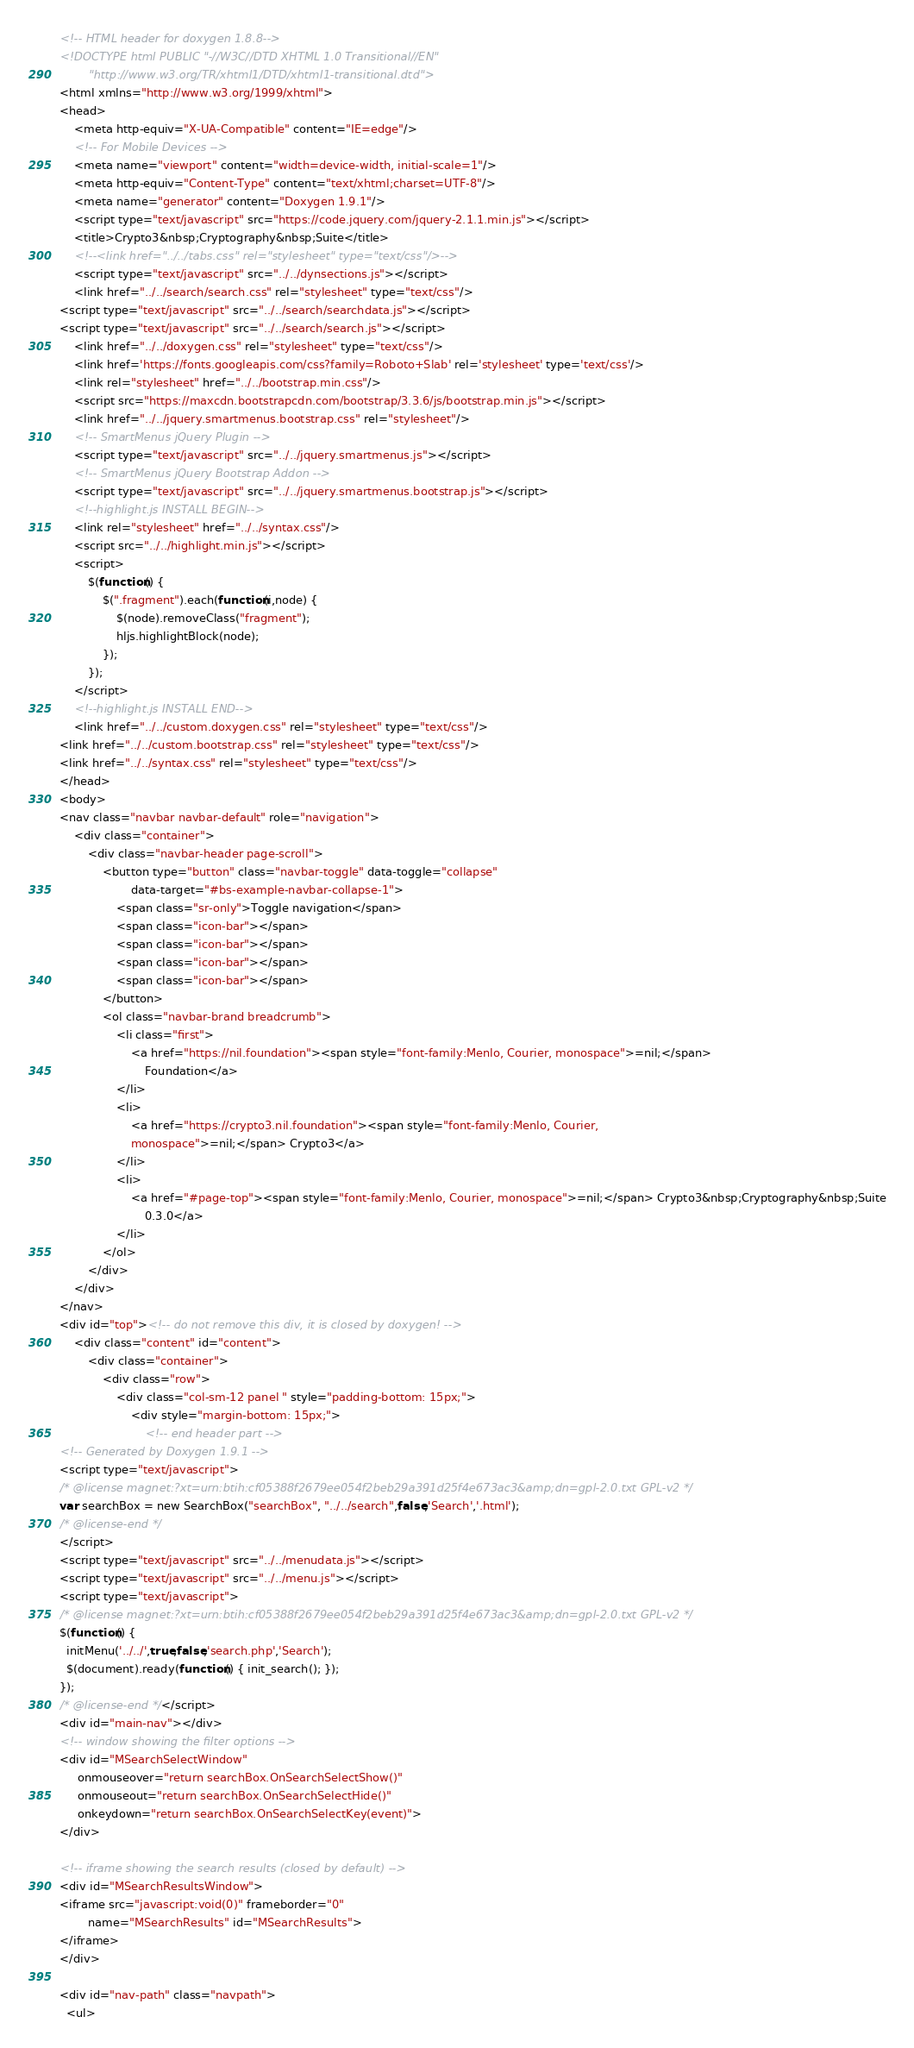<code> <loc_0><loc_0><loc_500><loc_500><_HTML_><!-- HTML header for doxygen 1.8.8-->
<!DOCTYPE html PUBLIC "-//W3C//DTD XHTML 1.0 Transitional//EN"
        "http://www.w3.org/TR/xhtml1/DTD/xhtml1-transitional.dtd">
<html xmlns="http://www.w3.org/1999/xhtml">
<head>
    <meta http-equiv="X-UA-Compatible" content="IE=edge"/>
    <!-- For Mobile Devices -->
    <meta name="viewport" content="width=device-width, initial-scale=1"/>
    <meta http-equiv="Content-Type" content="text/xhtml;charset=UTF-8"/>
    <meta name="generator" content="Doxygen 1.9.1"/>
    <script type="text/javascript" src="https://code.jquery.com/jquery-2.1.1.min.js"></script>
    <title>Crypto3&nbsp;Cryptography&nbsp;Suite</title>
    <!--<link href="../../tabs.css" rel="stylesheet" type="text/css"/>-->
    <script type="text/javascript" src="../../dynsections.js"></script>
    <link href="../../search/search.css" rel="stylesheet" type="text/css"/>
<script type="text/javascript" src="../../search/searchdata.js"></script>
<script type="text/javascript" src="../../search/search.js"></script>
    <link href="../../doxygen.css" rel="stylesheet" type="text/css"/>
    <link href='https://fonts.googleapis.com/css?family=Roboto+Slab' rel='stylesheet' type='text/css'/>
    <link rel="stylesheet" href="../../bootstrap.min.css"/>
    <script src="https://maxcdn.bootstrapcdn.com/bootstrap/3.3.6/js/bootstrap.min.js"></script>
    <link href="../../jquery.smartmenus.bootstrap.css" rel="stylesheet"/>
    <!-- SmartMenus jQuery Plugin -->
    <script type="text/javascript" src="../../jquery.smartmenus.js"></script>
    <!-- SmartMenus jQuery Bootstrap Addon -->
    <script type="text/javascript" src="../../jquery.smartmenus.bootstrap.js"></script>
    <!--highlight.js INSTALL BEGIN-->
    <link rel="stylesheet" href="../../syntax.css"/>
    <script src="../../highlight.min.js"></script>
    <script>
        $(function() {
            $(".fragment").each(function(i,node) {
                $(node).removeClass("fragment");
                hljs.highlightBlock(node);
            });
        });
    </script>
    <!--highlight.js INSTALL END-->
    <link href="../../custom.doxygen.css" rel="stylesheet" type="text/css"/>
<link href="../../custom.bootstrap.css" rel="stylesheet" type="text/css"/>
<link href="../../syntax.css" rel="stylesheet" type="text/css"/>
</head>
<body>
<nav class="navbar navbar-default" role="navigation">
    <div class="container">
        <div class="navbar-header page-scroll">
            <button type="button" class="navbar-toggle" data-toggle="collapse"
                    data-target="#bs-example-navbar-collapse-1">
                <span class="sr-only">Toggle navigation</span>
                <span class="icon-bar"></span>
                <span class="icon-bar"></span>
                <span class="icon-bar"></span>
                <span class="icon-bar"></span>
            </button>
            <ol class="navbar-brand breadcrumb">
                <li class="first">
                    <a href="https://nil.foundation"><span style="font-family:Menlo, Courier, monospace">=nil;</span>
                        Foundation</a>
                </li>
                <li>
                    <a href="https://crypto3.nil.foundation"><span style="font-family:Menlo, Courier,
                    monospace">=nil;</span> Crypto3</a>
                </li>
                <li>
                    <a href="#page-top"><span style="font-family:Menlo, Courier, monospace">=nil;</span> Crypto3&nbsp;Cryptography&nbsp;Suite
                        0.3.0</a>
                </li>
            </ol>
        </div>
    </div>
</nav>
<div id="top"><!-- do not remove this div, it is closed by doxygen! -->
    <div class="content" id="content">
        <div class="container">
            <div class="row">
                <div class="col-sm-12 panel " style="padding-bottom: 15px;">
                    <div style="margin-bottom: 15px;">
                        <!-- end header part -->
<!-- Generated by Doxygen 1.9.1 -->
<script type="text/javascript">
/* @license magnet:?xt=urn:btih:cf05388f2679ee054f2beb29a391d25f4e673ac3&amp;dn=gpl-2.0.txt GPL-v2 */
var searchBox = new SearchBox("searchBox", "../../search",false,'Search','.html');
/* @license-end */
</script>
<script type="text/javascript" src="../../menudata.js"></script>
<script type="text/javascript" src="../../menu.js"></script>
<script type="text/javascript">
/* @license magnet:?xt=urn:btih:cf05388f2679ee054f2beb29a391d25f4e673ac3&amp;dn=gpl-2.0.txt GPL-v2 */
$(function() {
  initMenu('../../',true,false,'search.php','Search');
  $(document).ready(function() { init_search(); });
});
/* @license-end */</script>
<div id="main-nav"></div>
<!-- window showing the filter options -->
<div id="MSearchSelectWindow"
     onmouseover="return searchBox.OnSearchSelectShow()"
     onmouseout="return searchBox.OnSearchSelectHide()"
     onkeydown="return searchBox.OnSearchSelectKey(event)">
</div>

<!-- iframe showing the search results (closed by default) -->
<div id="MSearchResultsWindow">
<iframe src="javascript:void(0)" frameborder="0" 
        name="MSearchResults" id="MSearchResults">
</iframe>
</div>

<div id="nav-path" class="navpath">
  <ul></code> 